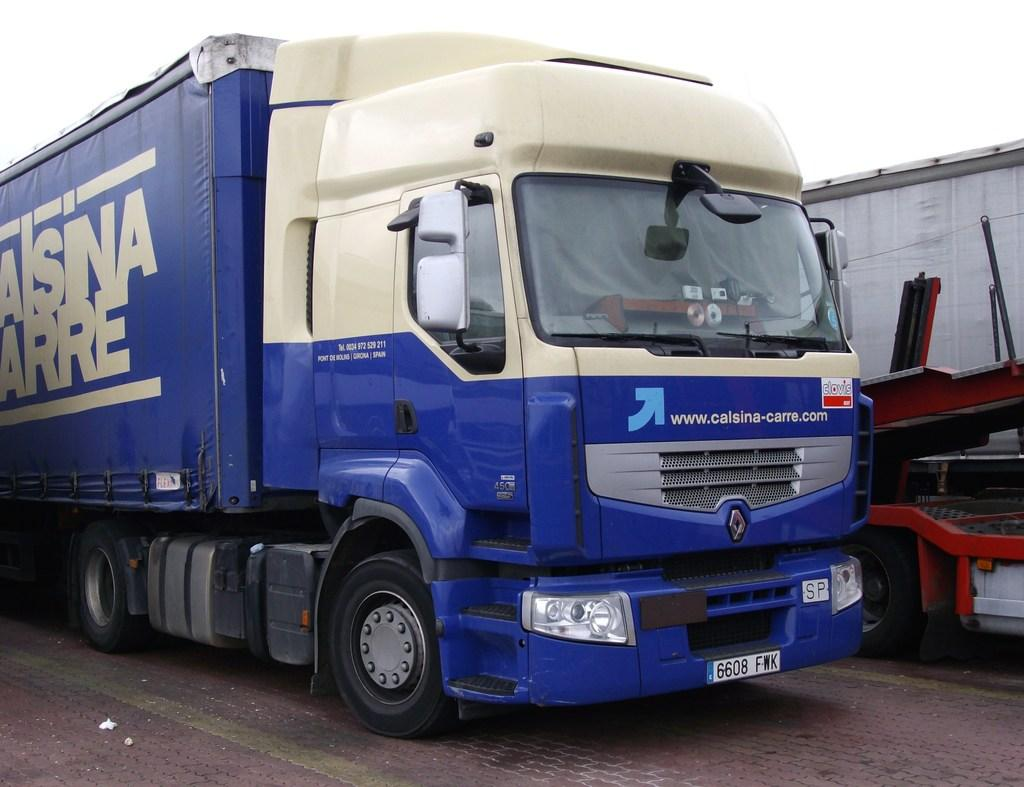What can be seen on the road in the image? There are vehicles on the road in the image. What is visible at the top of the image? The sky is visible at the top of the image. How many goats are visible on the top of the image? There are no goats visible on the top of the image; only the sky is visible. What type of voyage is depicted in the image? There is no voyage depicted in the image; it features vehicles on a road and the sky. 